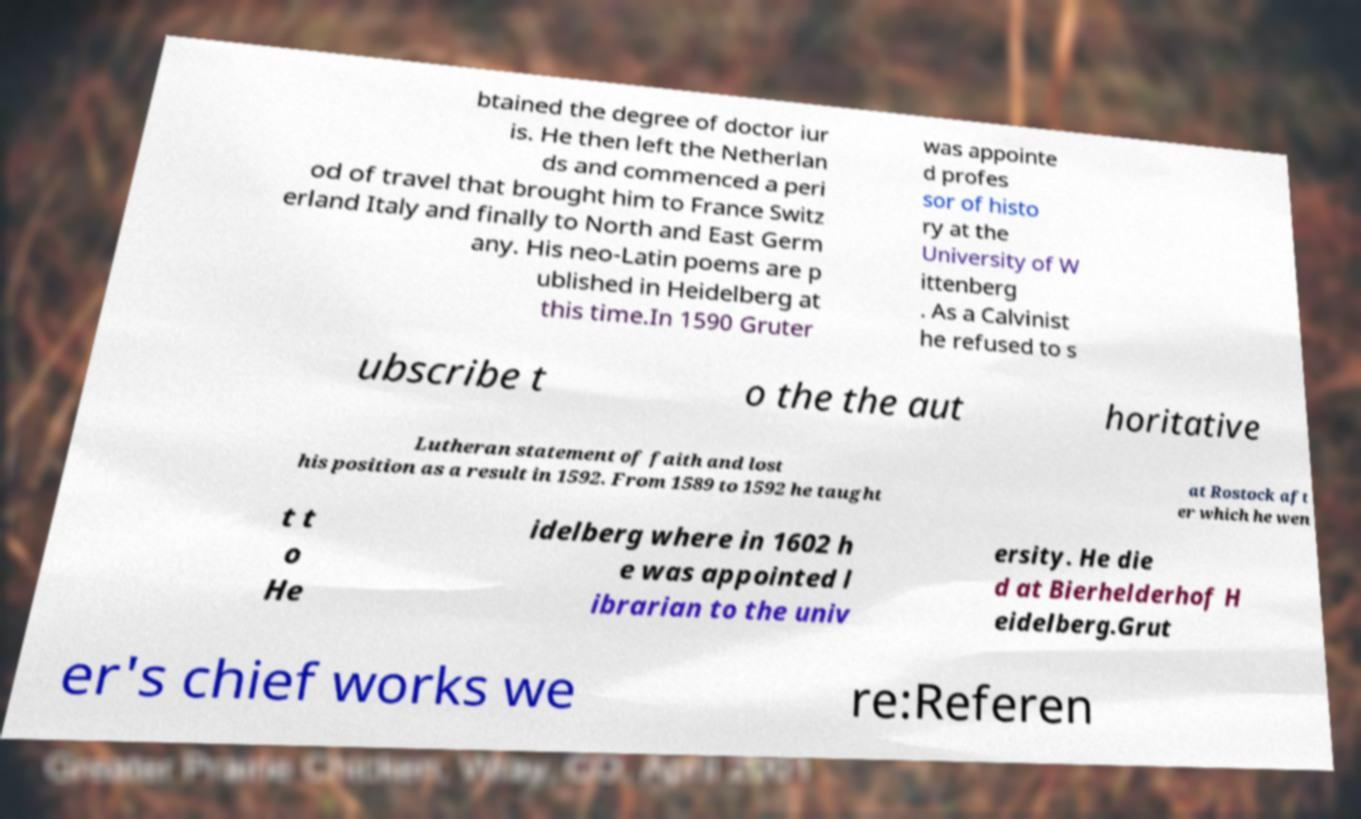There's text embedded in this image that I need extracted. Can you transcribe it verbatim? btained the degree of doctor iur is. He then left the Netherlan ds and commenced a peri od of travel that brought him to France Switz erland Italy and finally to North and East Germ any. His neo-Latin poems are p ublished in Heidelberg at this time.In 1590 Gruter was appointe d profes sor of histo ry at the University of W ittenberg . As a Calvinist he refused to s ubscribe t o the the aut horitative Lutheran statement of faith and lost his position as a result in 1592. From 1589 to 1592 he taught at Rostock aft er which he wen t t o He idelberg where in 1602 h e was appointed l ibrarian to the univ ersity. He die d at Bierhelderhof H eidelberg.Grut er's chief works we re:Referen 